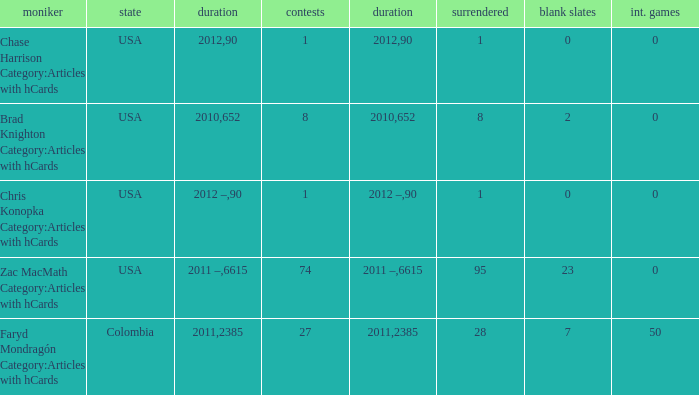When chase harrison category:articles with hcards is the name what is the year? 2012.0. 